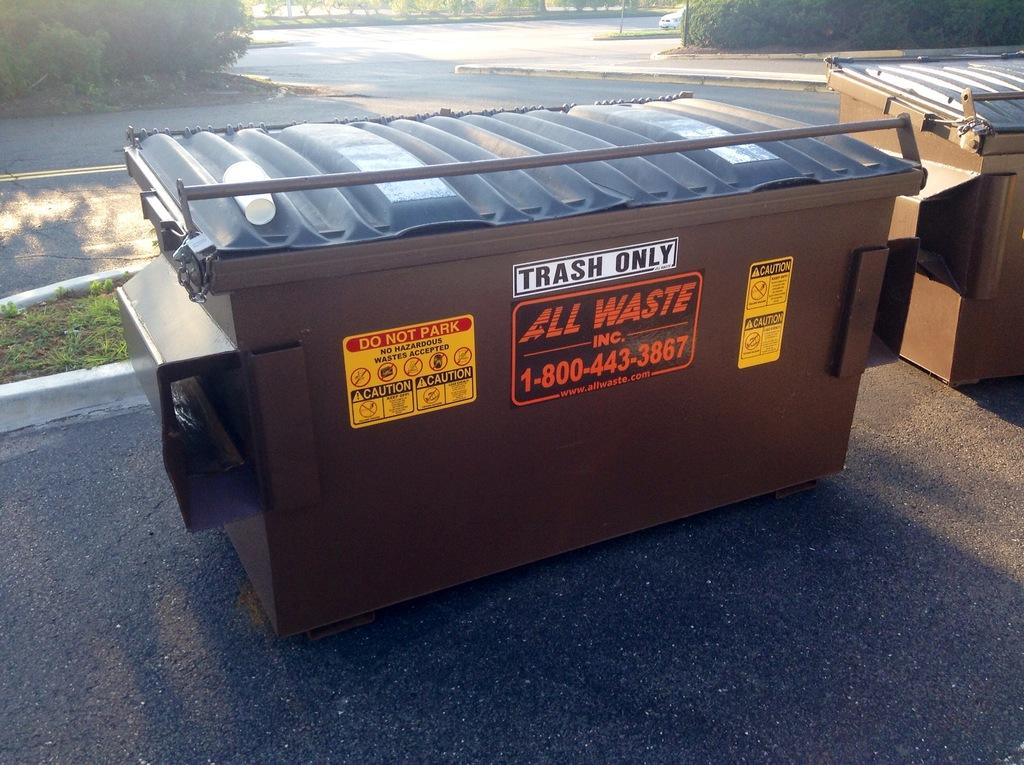Provide a one-sentence caption for the provided image. A brown dumpster from All Waste Inc. has a sign telling people that they can only put trash into it. 